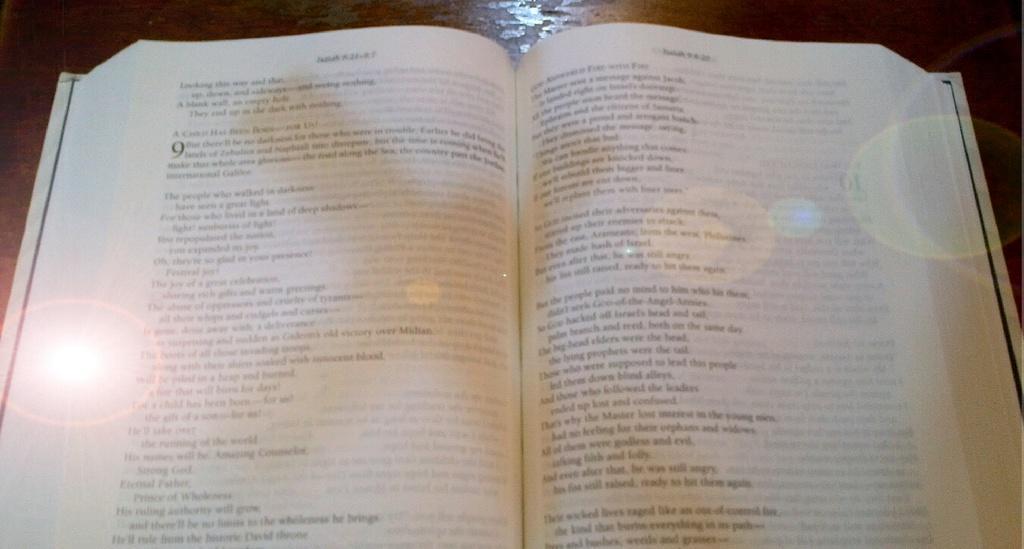Can you describe this image briefly? In the center of the image a book is present on the table. On book we can see some text is there. 